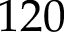<formula> <loc_0><loc_0><loc_500><loc_500>1 2 0</formula> 